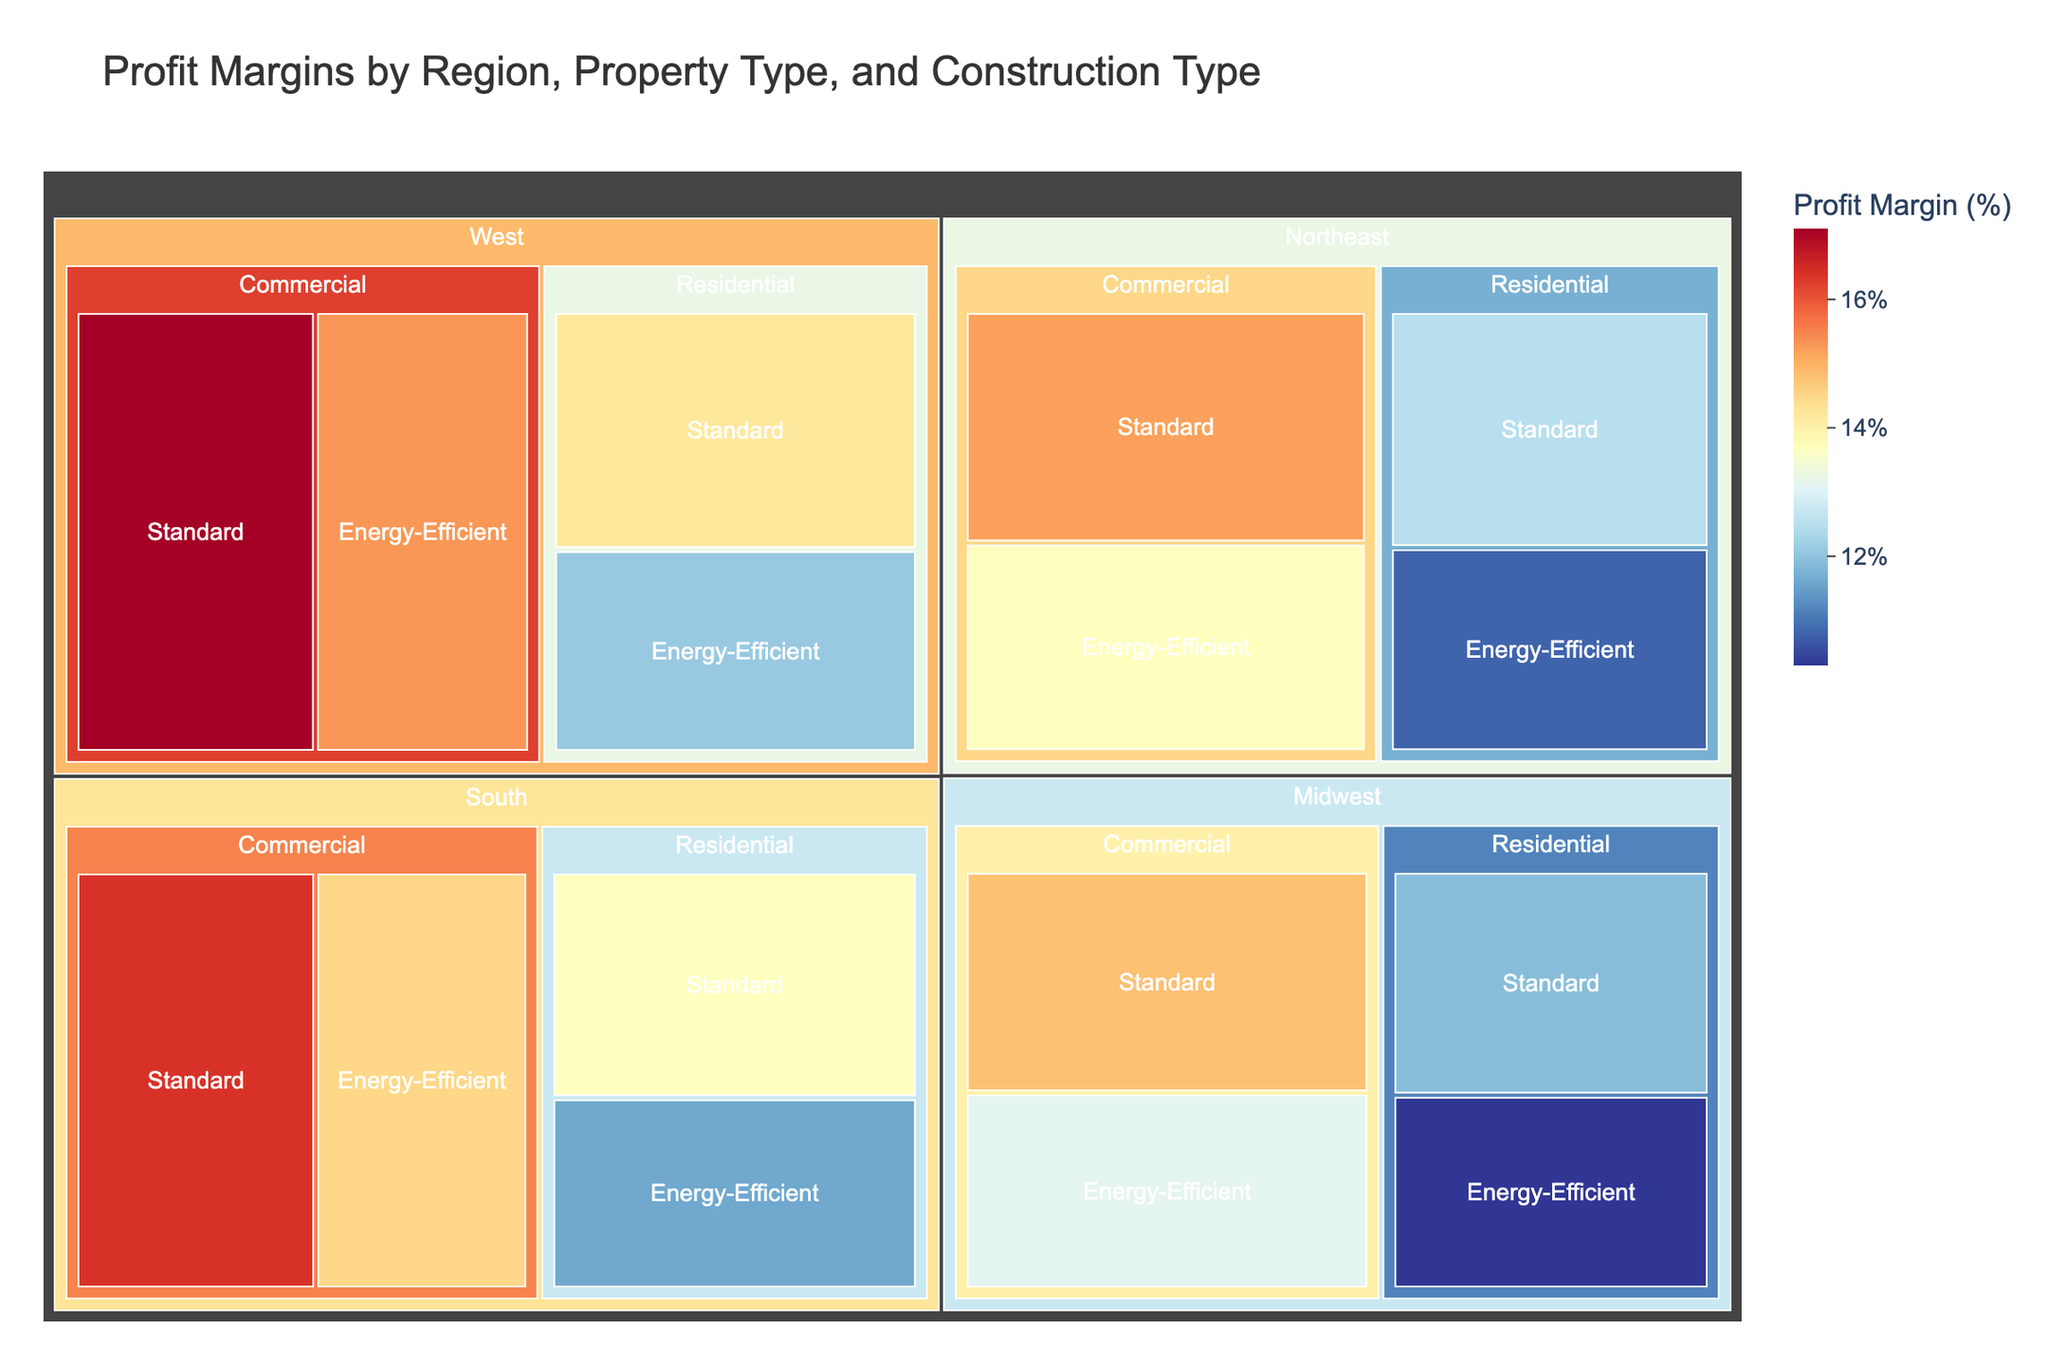What's the title of the figure? The title is typically placed at the top of the figure, and in this case, it states succinctly what the visualization is about.
Answer: Profit Margins by Region, Property Type, and Construction Type What is the profit margin for standard Residential properties in the South? Navigate to the South region, look for Residential property type, and identify the profit margin for standard construction.
Answer: 13.7% Which region has the highest profit margin for energy-efficient Commercial properties? Compare the profit margins for energy-efficient Commercial properties across all regions: Northeast, Midwest, South, and West, and identify the one with the highest value.
Answer: West How does the profit margin for standard Residential properties in the West compare to energy-efficient Residential properties in the same region? Check the profit margins for both standard and energy-efficient Residential properties in the West side-by-side to ascertain which is higher.
Answer: Standard: 14.2%, Energy-Efficient: 12.1% What is the range of profit margins for energy-efficient constructions across all regions and property types? Identify the highest and lowest profit margins for all energy-efficient constructions across various regions and property types, then calculate the difference. The highest is 15.3% (West, Commercial) and the lowest is 10.3% (Midwest, Residential).
Answer: 5% What is the average profit margin for all standard constructions in the Northeast region? List all profit margins for standard constructions in the Northeast (Residential and Commercial), sum them up, and divide by the number of data points (2). (12.5 + 15.2) / 2
Answer: 13.85% Do Commercial properties have uniformly higher profit margins than Residential properties for both standard and energy-efficient constructions across all regions? Inspect the profit margins of Commercial and Residential properties for both construction types across all regions and see if all Commercial property values are higher than Residential property values.
Answer: No, they do not uniformly have higher margins How many regions have a higher profit margin for standard Commercial properties than energy-efficient Commercial properties? For each region (Northeast, Midwest, South, West), compare the profit margins of standard and energy-efficient Commercial properties and count how many regions have higher margins for standard constructions.
Answer: 4 regions Which property type has the smallest difference in profit margins between standard and energy-efficient constructions in the Midwest? Calculate the differences for Residential and Commercial properties in the Midwest by subtracting the profit margin of energy-efficient construction from the standard one, then compare these differences.
Answer: Commercial (difference of 1.7%) What trend is observable between standard and energy-efficient constructions in terms of profit margins across regions? Analyze the profit margins for standard vs. energy-efficient constructions across all regions to determine if there is a consistent pattern like one typically being higher or the difference between them.
Answer: Standard constructions generally have higher profit margins 